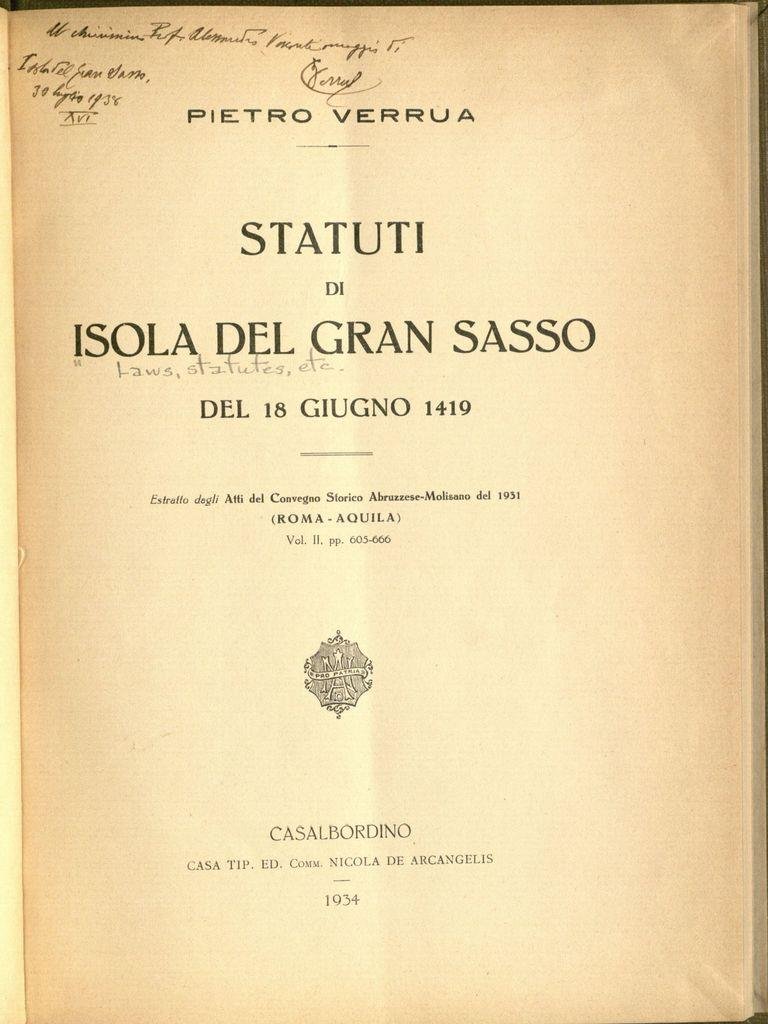<image>
Give a short and clear explanation of the subsequent image. A book is open to a page that says, "Statuti". 